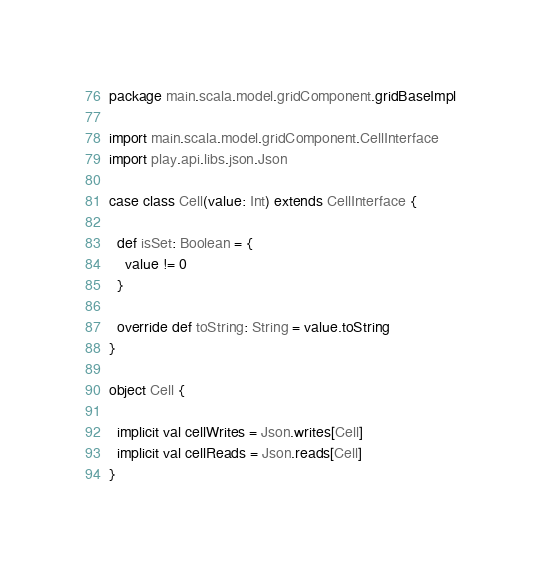<code> <loc_0><loc_0><loc_500><loc_500><_Scala_>package main.scala.model.gridComponent.gridBaseImpl

import main.scala.model.gridComponent.CellInterface
import play.api.libs.json.Json

case class Cell(value: Int) extends CellInterface {

  def isSet: Boolean = {
    value != 0
  }

  override def toString: String = value.toString
}

object Cell {

  implicit val cellWrites = Json.writes[Cell]
  implicit val cellReads = Json.reads[Cell]
}</code> 